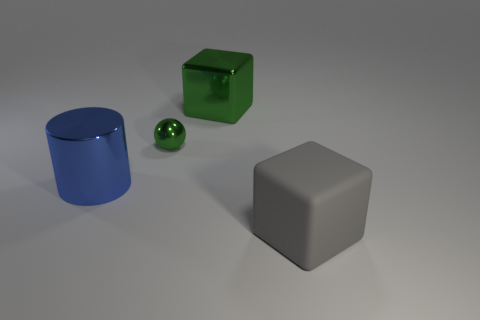How would the scene change if the sphere was replaced with a pyramid? Replacing the sphere with a pyramid would introduce a new element with flat surfaces and sharp edges, contrasting the other objects' smoothness and rounded edges. This might add a different visual dynamic, drawing more attention to the pyramid due to its distinctive shape. Could that affect the overall aesthetic of the image? Absolutely, the pyramid's angular form would introduce a sense of imbalance to the otherwise streamlined arrangement, potentially making the image look more striking and thought-provoking as the shapes present divergent geometric features. 